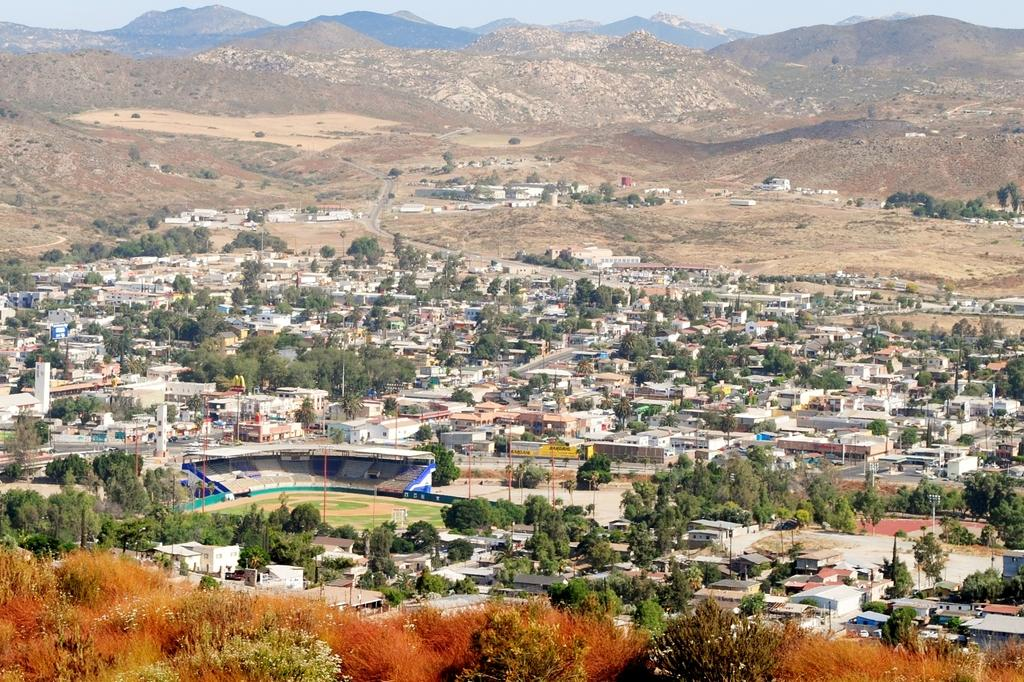What type of structures can be seen in the image? There are houses in the image. What natural elements are present in the image? There are trees and hills in the image. What type of polls are visible in the image? There are current polls in the image. What part of the natural environment is visible in the image? The sky is visible in the image. Can you see an airplane flying in the sky in the image? There is no airplane visible in the sky in the image. Is there a cannon present in the image? There is no cannon present in the image. 